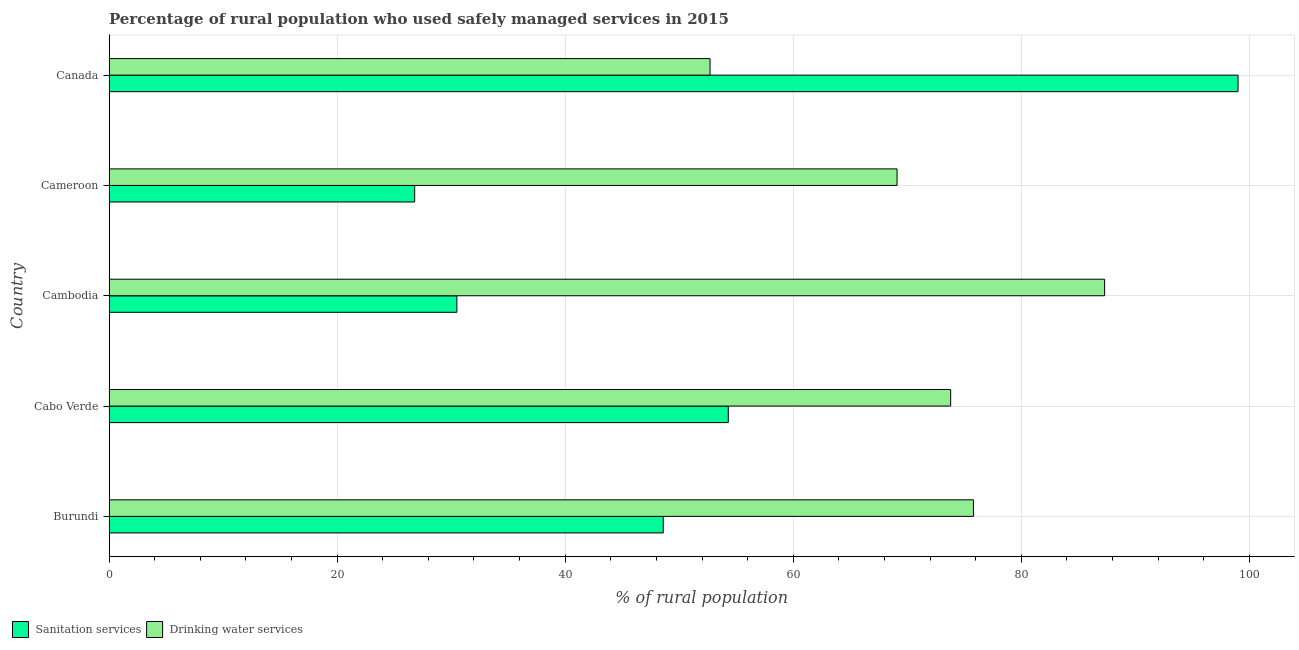How many groups of bars are there?
Offer a very short reply. 5. How many bars are there on the 5th tick from the top?
Your answer should be compact. 2. What is the label of the 4th group of bars from the top?
Offer a very short reply. Cabo Verde. In how many cases, is the number of bars for a given country not equal to the number of legend labels?
Make the answer very short. 0. What is the percentage of rural population who used sanitation services in Cambodia?
Provide a short and direct response. 30.5. Across all countries, what is the maximum percentage of rural population who used drinking water services?
Make the answer very short. 87.3. Across all countries, what is the minimum percentage of rural population who used sanitation services?
Your response must be concise. 26.8. In which country was the percentage of rural population who used drinking water services maximum?
Provide a succinct answer. Cambodia. In which country was the percentage of rural population who used sanitation services minimum?
Ensure brevity in your answer.  Cameroon. What is the total percentage of rural population who used sanitation services in the graph?
Ensure brevity in your answer.  259.2. What is the difference between the percentage of rural population who used sanitation services in Cameroon and the percentage of rural population who used drinking water services in Cabo Verde?
Offer a terse response. -47. What is the average percentage of rural population who used sanitation services per country?
Give a very brief answer. 51.84. What is the difference between the percentage of rural population who used drinking water services and percentage of rural population who used sanitation services in Burundi?
Your response must be concise. 27.2. In how many countries, is the percentage of rural population who used drinking water services greater than 32 %?
Your answer should be compact. 5. What is the ratio of the percentage of rural population who used sanitation services in Cabo Verde to that in Canada?
Ensure brevity in your answer.  0.55. Is the percentage of rural population who used drinking water services in Cambodia less than that in Canada?
Your response must be concise. No. Is the difference between the percentage of rural population who used sanitation services in Cambodia and Cameroon greater than the difference between the percentage of rural population who used drinking water services in Cambodia and Cameroon?
Keep it short and to the point. No. What is the difference between the highest and the lowest percentage of rural population who used sanitation services?
Give a very brief answer. 72.2. What does the 2nd bar from the top in Cambodia represents?
Provide a short and direct response. Sanitation services. What does the 2nd bar from the bottom in Cambodia represents?
Your response must be concise. Drinking water services. How many bars are there?
Provide a short and direct response. 10. Are all the bars in the graph horizontal?
Your response must be concise. Yes. Are the values on the major ticks of X-axis written in scientific E-notation?
Offer a terse response. No. Does the graph contain grids?
Make the answer very short. Yes. How many legend labels are there?
Provide a short and direct response. 2. How are the legend labels stacked?
Give a very brief answer. Horizontal. What is the title of the graph?
Make the answer very short. Percentage of rural population who used safely managed services in 2015. Does "Resident workers" appear as one of the legend labels in the graph?
Provide a short and direct response. No. What is the label or title of the X-axis?
Make the answer very short. % of rural population. What is the label or title of the Y-axis?
Your answer should be very brief. Country. What is the % of rural population of Sanitation services in Burundi?
Make the answer very short. 48.6. What is the % of rural population of Drinking water services in Burundi?
Offer a terse response. 75.8. What is the % of rural population in Sanitation services in Cabo Verde?
Provide a short and direct response. 54.3. What is the % of rural population of Drinking water services in Cabo Verde?
Your response must be concise. 73.8. What is the % of rural population in Sanitation services in Cambodia?
Offer a terse response. 30.5. What is the % of rural population in Drinking water services in Cambodia?
Give a very brief answer. 87.3. What is the % of rural population of Sanitation services in Cameroon?
Keep it short and to the point. 26.8. What is the % of rural population of Drinking water services in Cameroon?
Offer a very short reply. 69.1. What is the % of rural population in Sanitation services in Canada?
Your answer should be very brief. 99. What is the % of rural population in Drinking water services in Canada?
Offer a very short reply. 52.7. Across all countries, what is the maximum % of rural population of Sanitation services?
Offer a terse response. 99. Across all countries, what is the maximum % of rural population in Drinking water services?
Offer a terse response. 87.3. Across all countries, what is the minimum % of rural population in Sanitation services?
Make the answer very short. 26.8. Across all countries, what is the minimum % of rural population in Drinking water services?
Give a very brief answer. 52.7. What is the total % of rural population in Sanitation services in the graph?
Offer a very short reply. 259.2. What is the total % of rural population in Drinking water services in the graph?
Offer a very short reply. 358.7. What is the difference between the % of rural population in Sanitation services in Burundi and that in Cabo Verde?
Ensure brevity in your answer.  -5.7. What is the difference between the % of rural population of Sanitation services in Burundi and that in Cameroon?
Offer a terse response. 21.8. What is the difference between the % of rural population of Drinking water services in Burundi and that in Cameroon?
Your response must be concise. 6.7. What is the difference between the % of rural population of Sanitation services in Burundi and that in Canada?
Give a very brief answer. -50.4. What is the difference between the % of rural population of Drinking water services in Burundi and that in Canada?
Make the answer very short. 23.1. What is the difference between the % of rural population of Sanitation services in Cabo Verde and that in Cambodia?
Keep it short and to the point. 23.8. What is the difference between the % of rural population of Drinking water services in Cabo Verde and that in Cambodia?
Your response must be concise. -13.5. What is the difference between the % of rural population of Sanitation services in Cabo Verde and that in Cameroon?
Offer a very short reply. 27.5. What is the difference between the % of rural population in Drinking water services in Cabo Verde and that in Cameroon?
Provide a succinct answer. 4.7. What is the difference between the % of rural population in Sanitation services in Cabo Verde and that in Canada?
Offer a very short reply. -44.7. What is the difference between the % of rural population of Drinking water services in Cabo Verde and that in Canada?
Your response must be concise. 21.1. What is the difference between the % of rural population in Sanitation services in Cambodia and that in Cameroon?
Make the answer very short. 3.7. What is the difference between the % of rural population in Sanitation services in Cambodia and that in Canada?
Your answer should be compact. -68.5. What is the difference between the % of rural population of Drinking water services in Cambodia and that in Canada?
Provide a succinct answer. 34.6. What is the difference between the % of rural population in Sanitation services in Cameroon and that in Canada?
Give a very brief answer. -72.2. What is the difference between the % of rural population of Drinking water services in Cameroon and that in Canada?
Your answer should be compact. 16.4. What is the difference between the % of rural population in Sanitation services in Burundi and the % of rural population in Drinking water services in Cabo Verde?
Your answer should be very brief. -25.2. What is the difference between the % of rural population of Sanitation services in Burundi and the % of rural population of Drinking water services in Cambodia?
Make the answer very short. -38.7. What is the difference between the % of rural population of Sanitation services in Burundi and the % of rural population of Drinking water services in Cameroon?
Your response must be concise. -20.5. What is the difference between the % of rural population of Sanitation services in Burundi and the % of rural population of Drinking water services in Canada?
Your response must be concise. -4.1. What is the difference between the % of rural population in Sanitation services in Cabo Verde and the % of rural population in Drinking water services in Cambodia?
Your response must be concise. -33. What is the difference between the % of rural population in Sanitation services in Cabo Verde and the % of rural population in Drinking water services in Cameroon?
Offer a very short reply. -14.8. What is the difference between the % of rural population of Sanitation services in Cabo Verde and the % of rural population of Drinking water services in Canada?
Give a very brief answer. 1.6. What is the difference between the % of rural population in Sanitation services in Cambodia and the % of rural population in Drinking water services in Cameroon?
Keep it short and to the point. -38.6. What is the difference between the % of rural population of Sanitation services in Cambodia and the % of rural population of Drinking water services in Canada?
Keep it short and to the point. -22.2. What is the difference between the % of rural population of Sanitation services in Cameroon and the % of rural population of Drinking water services in Canada?
Your answer should be compact. -25.9. What is the average % of rural population of Sanitation services per country?
Offer a terse response. 51.84. What is the average % of rural population of Drinking water services per country?
Keep it short and to the point. 71.74. What is the difference between the % of rural population of Sanitation services and % of rural population of Drinking water services in Burundi?
Your answer should be very brief. -27.2. What is the difference between the % of rural population of Sanitation services and % of rural population of Drinking water services in Cabo Verde?
Your answer should be very brief. -19.5. What is the difference between the % of rural population in Sanitation services and % of rural population in Drinking water services in Cambodia?
Provide a succinct answer. -56.8. What is the difference between the % of rural population in Sanitation services and % of rural population in Drinking water services in Cameroon?
Ensure brevity in your answer.  -42.3. What is the difference between the % of rural population of Sanitation services and % of rural population of Drinking water services in Canada?
Make the answer very short. 46.3. What is the ratio of the % of rural population in Sanitation services in Burundi to that in Cabo Verde?
Keep it short and to the point. 0.9. What is the ratio of the % of rural population in Drinking water services in Burundi to that in Cabo Verde?
Give a very brief answer. 1.03. What is the ratio of the % of rural population of Sanitation services in Burundi to that in Cambodia?
Provide a short and direct response. 1.59. What is the ratio of the % of rural population of Drinking water services in Burundi to that in Cambodia?
Ensure brevity in your answer.  0.87. What is the ratio of the % of rural population in Sanitation services in Burundi to that in Cameroon?
Make the answer very short. 1.81. What is the ratio of the % of rural population in Drinking water services in Burundi to that in Cameroon?
Keep it short and to the point. 1.1. What is the ratio of the % of rural population of Sanitation services in Burundi to that in Canada?
Keep it short and to the point. 0.49. What is the ratio of the % of rural population of Drinking water services in Burundi to that in Canada?
Your answer should be very brief. 1.44. What is the ratio of the % of rural population of Sanitation services in Cabo Verde to that in Cambodia?
Your response must be concise. 1.78. What is the ratio of the % of rural population of Drinking water services in Cabo Verde to that in Cambodia?
Give a very brief answer. 0.85. What is the ratio of the % of rural population in Sanitation services in Cabo Verde to that in Cameroon?
Provide a succinct answer. 2.03. What is the ratio of the % of rural population of Drinking water services in Cabo Verde to that in Cameroon?
Provide a short and direct response. 1.07. What is the ratio of the % of rural population in Sanitation services in Cabo Verde to that in Canada?
Make the answer very short. 0.55. What is the ratio of the % of rural population of Drinking water services in Cabo Verde to that in Canada?
Keep it short and to the point. 1.4. What is the ratio of the % of rural population of Sanitation services in Cambodia to that in Cameroon?
Your answer should be compact. 1.14. What is the ratio of the % of rural population in Drinking water services in Cambodia to that in Cameroon?
Keep it short and to the point. 1.26. What is the ratio of the % of rural population in Sanitation services in Cambodia to that in Canada?
Provide a short and direct response. 0.31. What is the ratio of the % of rural population of Drinking water services in Cambodia to that in Canada?
Your answer should be compact. 1.66. What is the ratio of the % of rural population of Sanitation services in Cameroon to that in Canada?
Make the answer very short. 0.27. What is the ratio of the % of rural population of Drinking water services in Cameroon to that in Canada?
Ensure brevity in your answer.  1.31. What is the difference between the highest and the second highest % of rural population of Sanitation services?
Your answer should be compact. 44.7. What is the difference between the highest and the second highest % of rural population in Drinking water services?
Keep it short and to the point. 11.5. What is the difference between the highest and the lowest % of rural population of Sanitation services?
Make the answer very short. 72.2. What is the difference between the highest and the lowest % of rural population of Drinking water services?
Your answer should be compact. 34.6. 